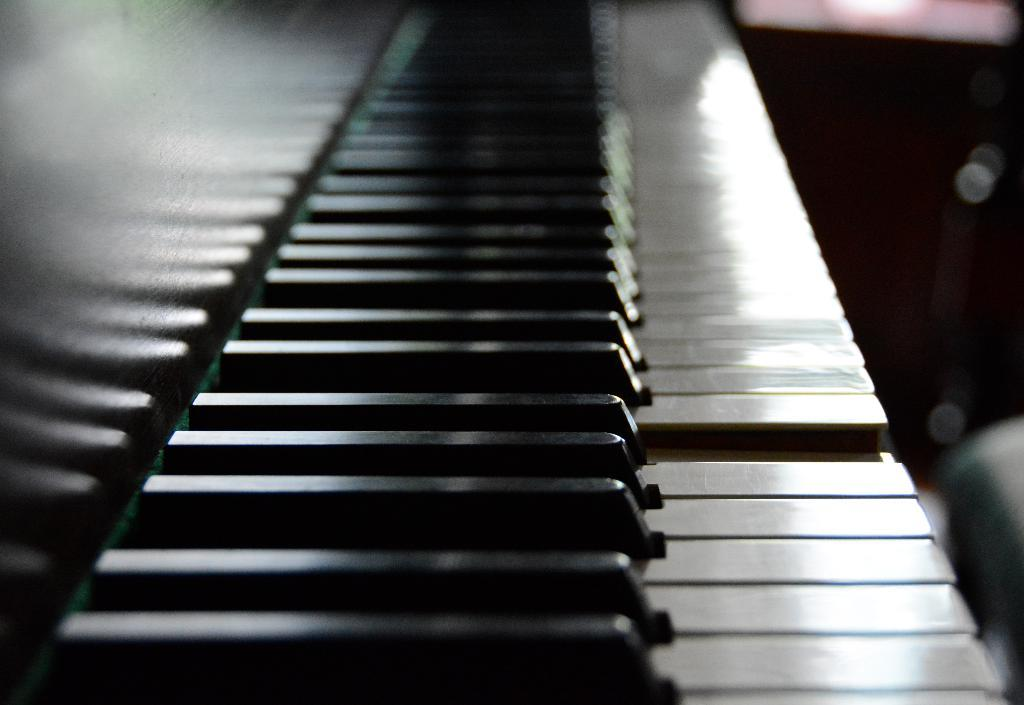What is the main subject of the picture? The main subject of the picture is a piano keyboard. How is the piano keyboard being emphasized in the image? The piano keyboard is highlighted in the picture. What type of coach can be seen in the picture? There is no coach present in the picture; it features a highlighted piano keyboard. What type of bun is visible on the piano keyboard? There is no bun present on the piano keyboard; it is a musical instrument with keys. 